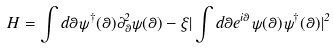Convert formula to latex. <formula><loc_0><loc_0><loc_500><loc_500>H = \int d \theta \psi ^ { \dag } ( \theta ) \partial ^ { 2 } _ { \theta } \psi ( \theta ) - \xi | \int d \theta e ^ { i \theta } \psi ( \theta ) \psi ^ { \dag } ( \theta ) | ^ { 2 }</formula> 